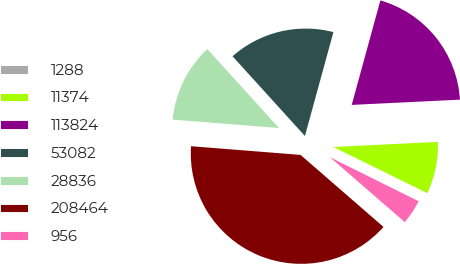Convert chart. <chart><loc_0><loc_0><loc_500><loc_500><pie_chart><fcel>1288<fcel>11374<fcel>113824<fcel>53082<fcel>28836<fcel>208464<fcel>956<nl><fcel>0.07%<fcel>8.03%<fcel>19.97%<fcel>15.99%<fcel>12.01%<fcel>39.88%<fcel>4.05%<nl></chart> 